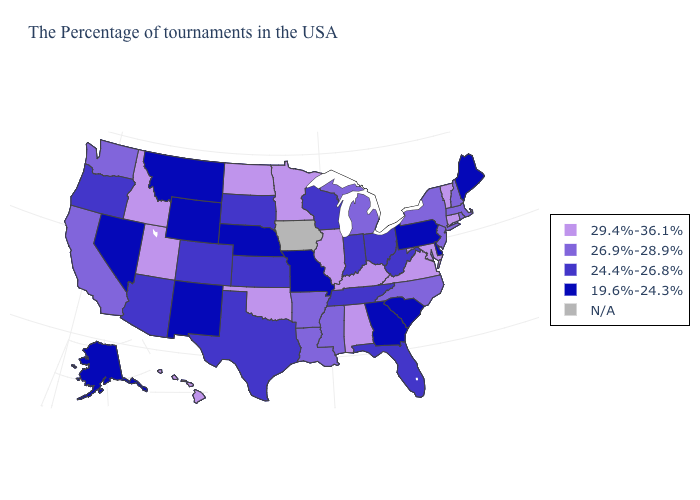Name the states that have a value in the range 24.4%-26.8%?
Quick response, please. West Virginia, Ohio, Florida, Indiana, Tennessee, Wisconsin, Kansas, Texas, South Dakota, Colorado, Arizona, Oregon. Name the states that have a value in the range 19.6%-24.3%?
Give a very brief answer. Maine, Delaware, Pennsylvania, South Carolina, Georgia, Missouri, Nebraska, Wyoming, New Mexico, Montana, Nevada, Alaska. Name the states that have a value in the range 26.9%-28.9%?
Keep it brief. Massachusetts, Rhode Island, New Hampshire, New York, New Jersey, North Carolina, Michigan, Mississippi, Louisiana, Arkansas, California, Washington. What is the lowest value in the USA?
Give a very brief answer. 19.6%-24.3%. Name the states that have a value in the range 26.9%-28.9%?
Keep it brief. Massachusetts, Rhode Island, New Hampshire, New York, New Jersey, North Carolina, Michigan, Mississippi, Louisiana, Arkansas, California, Washington. What is the value of Nevada?
Quick response, please. 19.6%-24.3%. What is the lowest value in the Northeast?
Give a very brief answer. 19.6%-24.3%. What is the value of New Hampshire?
Concise answer only. 26.9%-28.9%. Name the states that have a value in the range 26.9%-28.9%?
Short answer required. Massachusetts, Rhode Island, New Hampshire, New York, New Jersey, North Carolina, Michigan, Mississippi, Louisiana, Arkansas, California, Washington. Name the states that have a value in the range 26.9%-28.9%?
Keep it brief. Massachusetts, Rhode Island, New Hampshire, New York, New Jersey, North Carolina, Michigan, Mississippi, Louisiana, Arkansas, California, Washington. What is the highest value in states that border Georgia?
Concise answer only. 29.4%-36.1%. Does Connecticut have the highest value in the Northeast?
Short answer required. Yes. Name the states that have a value in the range N/A?
Write a very short answer. Iowa. Does Alaska have the lowest value in the USA?
Give a very brief answer. Yes. 